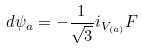<formula> <loc_0><loc_0><loc_500><loc_500>d \psi _ { a } = - \frac { 1 } { \sqrt { 3 } } i _ { V _ { ( a ) } } F</formula> 